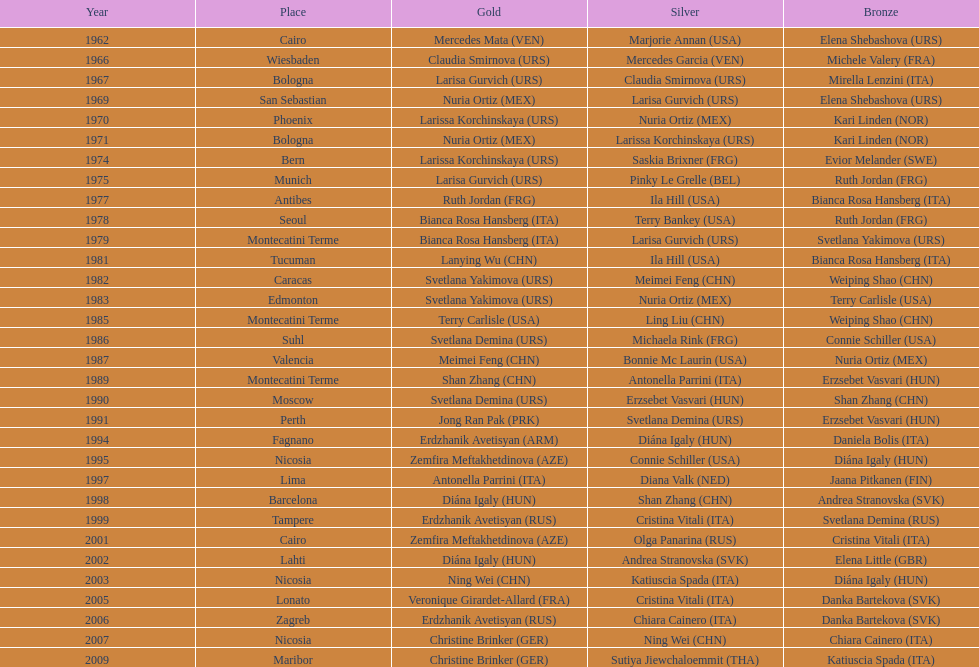Has china or mexico garnered more gold medals in their history? China. 